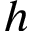<formula> <loc_0><loc_0><loc_500><loc_500>h</formula> 